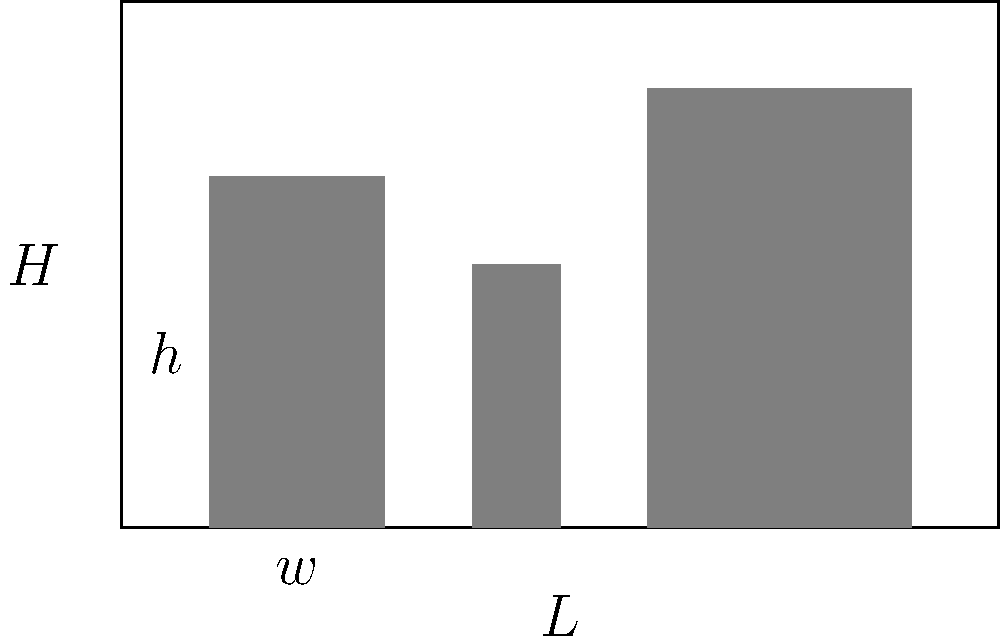A library shelf has a length $L$ of 10 feet and a height $H$ of 6 feet. Books of uniform thickness are to be arranged on this shelf. Each book has a width $w$ and a height $h$. The goal is to maximize the number of books that can fit on the shelf. If the ratio of book height to width is fixed at 2:1 (i.e., $h = 2w$), what should be the dimensions of each book to maximize the number of books on the shelf? Let's approach this step-by-step:

1) The number of books that can fit horizontally is $\frac{L}{w}$, and vertically is $\frac{H}{h}$.

2) The total number of books $N$ is the product of these:
   $N = \frac{L}{w} \cdot \frac{H}{h}$

3) We're given that $h = 2w$, so we can substitute this:
   $N = \frac{L}{w} \cdot \frac{H}{2w} = \frac{LH}{2w^2}$

4) We want to maximize $N$. Since $L$ and $H$ are constants, this is equivalent to minimizing $w^2$.

5) However, we need to consider the constraint that the books must fit on the shelf. The height of the books can't exceed the shelf height:
   $2w \leq H$, or $w \leq \frac{H}{2}$

6) To maximize $N$, we should use the largest possible $w$ that satisfies this constraint. Therefore:
   $w = \frac{H}{2} = \frac{6}{2} = 3$ feet

7) Since $h = 2w$, the height of each book should be:
   $h = 2(3) = 6$ feet

8) These dimensions ensure that the books fit perfectly in the vertical dimension, maximizing the use of shelf space.
Answer: $w = 3$ feet, $h = 6$ feet 